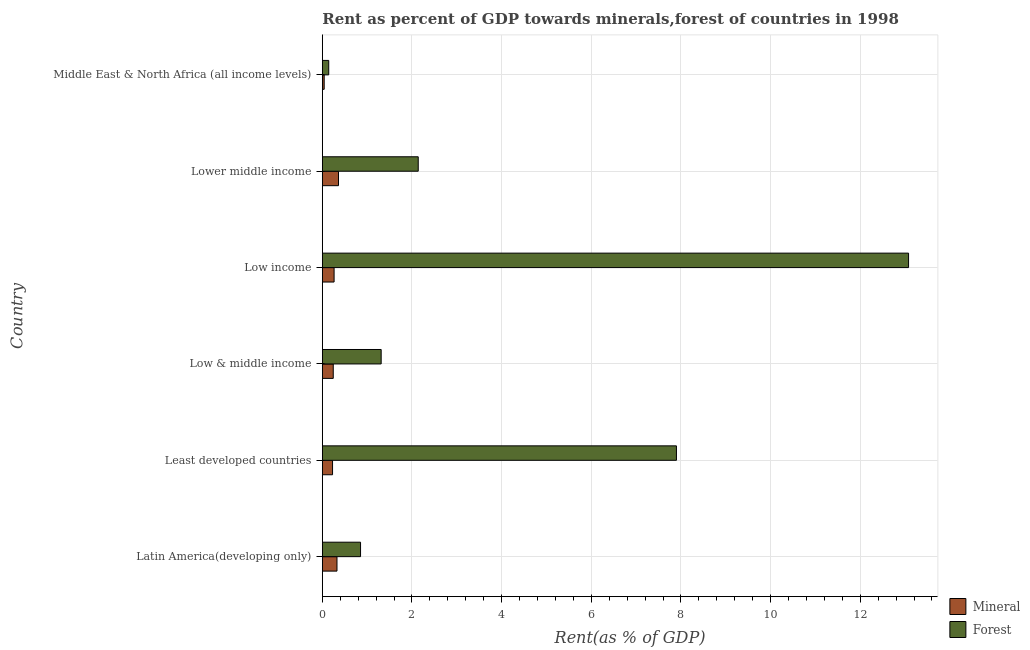How many different coloured bars are there?
Offer a very short reply. 2. How many groups of bars are there?
Provide a succinct answer. 6. What is the label of the 5th group of bars from the top?
Make the answer very short. Least developed countries. What is the forest rent in Lower middle income?
Your answer should be compact. 2.14. Across all countries, what is the maximum mineral rent?
Ensure brevity in your answer.  0.36. Across all countries, what is the minimum mineral rent?
Keep it short and to the point. 0.04. In which country was the mineral rent minimum?
Provide a succinct answer. Middle East & North Africa (all income levels). What is the total forest rent in the graph?
Your response must be concise. 25.42. What is the difference between the mineral rent in Low income and that in Lower middle income?
Offer a terse response. -0.1. What is the difference between the forest rent in Latin America(developing only) and the mineral rent in Low income?
Provide a succinct answer. 0.59. What is the average forest rent per country?
Your response must be concise. 4.24. What is the difference between the mineral rent and forest rent in Low & middle income?
Your response must be concise. -1.07. In how many countries, is the mineral rent greater than 12.4 %?
Provide a short and direct response. 0. What is the ratio of the mineral rent in Lower middle income to that in Middle East & North Africa (all income levels)?
Offer a terse response. 8.7. Is the forest rent in Least developed countries less than that in Low & middle income?
Provide a short and direct response. No. What is the difference between the highest and the second highest forest rent?
Give a very brief answer. 5.18. What is the difference between the highest and the lowest forest rent?
Make the answer very short. 12.93. In how many countries, is the forest rent greater than the average forest rent taken over all countries?
Offer a very short reply. 2. Is the sum of the mineral rent in Least developed countries and Low & middle income greater than the maximum forest rent across all countries?
Your answer should be compact. No. What does the 2nd bar from the top in Low income represents?
Your answer should be very brief. Mineral. What does the 1st bar from the bottom in Low income represents?
Your answer should be compact. Mineral. Are all the bars in the graph horizontal?
Your answer should be compact. Yes. What is the difference between two consecutive major ticks on the X-axis?
Your answer should be very brief. 2. Does the graph contain any zero values?
Your answer should be compact. No. How are the legend labels stacked?
Provide a short and direct response. Vertical. What is the title of the graph?
Offer a very short reply. Rent as percent of GDP towards minerals,forest of countries in 1998. What is the label or title of the X-axis?
Your answer should be very brief. Rent(as % of GDP). What is the label or title of the Y-axis?
Provide a succinct answer. Country. What is the Rent(as % of GDP) of Mineral in Latin America(developing only)?
Your answer should be compact. 0.33. What is the Rent(as % of GDP) of Forest in Latin America(developing only)?
Provide a short and direct response. 0.85. What is the Rent(as % of GDP) of Mineral in Least developed countries?
Provide a short and direct response. 0.23. What is the Rent(as % of GDP) in Forest in Least developed countries?
Ensure brevity in your answer.  7.9. What is the Rent(as % of GDP) in Mineral in Low & middle income?
Provide a short and direct response. 0.24. What is the Rent(as % of GDP) in Forest in Low & middle income?
Your response must be concise. 1.31. What is the Rent(as % of GDP) of Mineral in Low income?
Offer a terse response. 0.26. What is the Rent(as % of GDP) of Forest in Low income?
Make the answer very short. 13.08. What is the Rent(as % of GDP) in Mineral in Lower middle income?
Make the answer very short. 0.36. What is the Rent(as % of GDP) in Forest in Lower middle income?
Offer a terse response. 2.14. What is the Rent(as % of GDP) of Mineral in Middle East & North Africa (all income levels)?
Offer a very short reply. 0.04. What is the Rent(as % of GDP) in Forest in Middle East & North Africa (all income levels)?
Provide a succinct answer. 0.14. Across all countries, what is the maximum Rent(as % of GDP) in Mineral?
Provide a succinct answer. 0.36. Across all countries, what is the maximum Rent(as % of GDP) of Forest?
Your answer should be compact. 13.08. Across all countries, what is the minimum Rent(as % of GDP) of Mineral?
Offer a terse response. 0.04. Across all countries, what is the minimum Rent(as % of GDP) in Forest?
Provide a short and direct response. 0.14. What is the total Rent(as % of GDP) of Mineral in the graph?
Offer a terse response. 1.46. What is the total Rent(as % of GDP) of Forest in the graph?
Your answer should be very brief. 25.42. What is the difference between the Rent(as % of GDP) in Mineral in Latin America(developing only) and that in Least developed countries?
Make the answer very short. 0.1. What is the difference between the Rent(as % of GDP) of Forest in Latin America(developing only) and that in Least developed countries?
Offer a terse response. -7.05. What is the difference between the Rent(as % of GDP) of Mineral in Latin America(developing only) and that in Low & middle income?
Ensure brevity in your answer.  0.08. What is the difference between the Rent(as % of GDP) of Forest in Latin America(developing only) and that in Low & middle income?
Make the answer very short. -0.46. What is the difference between the Rent(as % of GDP) of Mineral in Latin America(developing only) and that in Low income?
Your answer should be compact. 0.06. What is the difference between the Rent(as % of GDP) in Forest in Latin America(developing only) and that in Low income?
Offer a terse response. -12.22. What is the difference between the Rent(as % of GDP) in Mineral in Latin America(developing only) and that in Lower middle income?
Make the answer very short. -0.03. What is the difference between the Rent(as % of GDP) of Forest in Latin America(developing only) and that in Lower middle income?
Keep it short and to the point. -1.29. What is the difference between the Rent(as % of GDP) of Mineral in Latin America(developing only) and that in Middle East & North Africa (all income levels)?
Give a very brief answer. 0.29. What is the difference between the Rent(as % of GDP) of Forest in Latin America(developing only) and that in Middle East & North Africa (all income levels)?
Keep it short and to the point. 0.71. What is the difference between the Rent(as % of GDP) in Mineral in Least developed countries and that in Low & middle income?
Provide a short and direct response. -0.02. What is the difference between the Rent(as % of GDP) in Forest in Least developed countries and that in Low & middle income?
Your answer should be compact. 6.59. What is the difference between the Rent(as % of GDP) of Mineral in Least developed countries and that in Low income?
Provide a short and direct response. -0.03. What is the difference between the Rent(as % of GDP) in Forest in Least developed countries and that in Low income?
Keep it short and to the point. -5.18. What is the difference between the Rent(as % of GDP) in Mineral in Least developed countries and that in Lower middle income?
Offer a very short reply. -0.13. What is the difference between the Rent(as % of GDP) in Forest in Least developed countries and that in Lower middle income?
Provide a short and direct response. 5.76. What is the difference between the Rent(as % of GDP) of Mineral in Least developed countries and that in Middle East & North Africa (all income levels)?
Your answer should be very brief. 0.19. What is the difference between the Rent(as % of GDP) of Forest in Least developed countries and that in Middle East & North Africa (all income levels)?
Your answer should be compact. 7.76. What is the difference between the Rent(as % of GDP) in Mineral in Low & middle income and that in Low income?
Give a very brief answer. -0.02. What is the difference between the Rent(as % of GDP) of Forest in Low & middle income and that in Low income?
Your response must be concise. -11.76. What is the difference between the Rent(as % of GDP) in Mineral in Low & middle income and that in Lower middle income?
Provide a short and direct response. -0.12. What is the difference between the Rent(as % of GDP) of Forest in Low & middle income and that in Lower middle income?
Your answer should be very brief. -0.83. What is the difference between the Rent(as % of GDP) of Mineral in Low & middle income and that in Middle East & North Africa (all income levels)?
Your response must be concise. 0.2. What is the difference between the Rent(as % of GDP) in Forest in Low & middle income and that in Middle East & North Africa (all income levels)?
Offer a very short reply. 1.17. What is the difference between the Rent(as % of GDP) of Mineral in Low income and that in Lower middle income?
Ensure brevity in your answer.  -0.1. What is the difference between the Rent(as % of GDP) in Forest in Low income and that in Lower middle income?
Your response must be concise. 10.94. What is the difference between the Rent(as % of GDP) in Mineral in Low income and that in Middle East & North Africa (all income levels)?
Your answer should be compact. 0.22. What is the difference between the Rent(as % of GDP) in Forest in Low income and that in Middle East & North Africa (all income levels)?
Ensure brevity in your answer.  12.93. What is the difference between the Rent(as % of GDP) of Mineral in Lower middle income and that in Middle East & North Africa (all income levels)?
Your answer should be very brief. 0.32. What is the difference between the Rent(as % of GDP) in Forest in Lower middle income and that in Middle East & North Africa (all income levels)?
Make the answer very short. 2. What is the difference between the Rent(as % of GDP) in Mineral in Latin America(developing only) and the Rent(as % of GDP) in Forest in Least developed countries?
Your answer should be very brief. -7.57. What is the difference between the Rent(as % of GDP) in Mineral in Latin America(developing only) and the Rent(as % of GDP) in Forest in Low & middle income?
Make the answer very short. -0.99. What is the difference between the Rent(as % of GDP) in Mineral in Latin America(developing only) and the Rent(as % of GDP) in Forest in Low income?
Provide a succinct answer. -12.75. What is the difference between the Rent(as % of GDP) in Mineral in Latin America(developing only) and the Rent(as % of GDP) in Forest in Lower middle income?
Make the answer very short. -1.81. What is the difference between the Rent(as % of GDP) in Mineral in Latin America(developing only) and the Rent(as % of GDP) in Forest in Middle East & North Africa (all income levels)?
Provide a short and direct response. 0.18. What is the difference between the Rent(as % of GDP) of Mineral in Least developed countries and the Rent(as % of GDP) of Forest in Low & middle income?
Make the answer very short. -1.08. What is the difference between the Rent(as % of GDP) of Mineral in Least developed countries and the Rent(as % of GDP) of Forest in Low income?
Make the answer very short. -12.85. What is the difference between the Rent(as % of GDP) of Mineral in Least developed countries and the Rent(as % of GDP) of Forest in Lower middle income?
Your answer should be compact. -1.91. What is the difference between the Rent(as % of GDP) in Mineral in Least developed countries and the Rent(as % of GDP) in Forest in Middle East & North Africa (all income levels)?
Your response must be concise. 0.08. What is the difference between the Rent(as % of GDP) of Mineral in Low & middle income and the Rent(as % of GDP) of Forest in Low income?
Give a very brief answer. -12.83. What is the difference between the Rent(as % of GDP) of Mineral in Low & middle income and the Rent(as % of GDP) of Forest in Lower middle income?
Offer a very short reply. -1.9. What is the difference between the Rent(as % of GDP) of Mineral in Low & middle income and the Rent(as % of GDP) of Forest in Middle East & North Africa (all income levels)?
Give a very brief answer. 0.1. What is the difference between the Rent(as % of GDP) of Mineral in Low income and the Rent(as % of GDP) of Forest in Lower middle income?
Make the answer very short. -1.88. What is the difference between the Rent(as % of GDP) of Mineral in Low income and the Rent(as % of GDP) of Forest in Middle East & North Africa (all income levels)?
Provide a succinct answer. 0.12. What is the difference between the Rent(as % of GDP) in Mineral in Lower middle income and the Rent(as % of GDP) in Forest in Middle East & North Africa (all income levels)?
Make the answer very short. 0.22. What is the average Rent(as % of GDP) of Mineral per country?
Offer a terse response. 0.24. What is the average Rent(as % of GDP) in Forest per country?
Your response must be concise. 4.24. What is the difference between the Rent(as % of GDP) in Mineral and Rent(as % of GDP) in Forest in Latin America(developing only)?
Your response must be concise. -0.53. What is the difference between the Rent(as % of GDP) in Mineral and Rent(as % of GDP) in Forest in Least developed countries?
Make the answer very short. -7.67. What is the difference between the Rent(as % of GDP) in Mineral and Rent(as % of GDP) in Forest in Low & middle income?
Give a very brief answer. -1.07. What is the difference between the Rent(as % of GDP) of Mineral and Rent(as % of GDP) of Forest in Low income?
Your response must be concise. -12.81. What is the difference between the Rent(as % of GDP) in Mineral and Rent(as % of GDP) in Forest in Lower middle income?
Give a very brief answer. -1.78. What is the difference between the Rent(as % of GDP) of Mineral and Rent(as % of GDP) of Forest in Middle East & North Africa (all income levels)?
Make the answer very short. -0.1. What is the ratio of the Rent(as % of GDP) of Mineral in Latin America(developing only) to that in Least developed countries?
Offer a very short reply. 1.43. What is the ratio of the Rent(as % of GDP) in Forest in Latin America(developing only) to that in Least developed countries?
Ensure brevity in your answer.  0.11. What is the ratio of the Rent(as % of GDP) in Mineral in Latin America(developing only) to that in Low & middle income?
Your response must be concise. 1.34. What is the ratio of the Rent(as % of GDP) of Forest in Latin America(developing only) to that in Low & middle income?
Your answer should be very brief. 0.65. What is the ratio of the Rent(as % of GDP) in Mineral in Latin America(developing only) to that in Low income?
Ensure brevity in your answer.  1.25. What is the ratio of the Rent(as % of GDP) in Forest in Latin America(developing only) to that in Low income?
Provide a short and direct response. 0.07. What is the ratio of the Rent(as % of GDP) in Mineral in Latin America(developing only) to that in Lower middle income?
Offer a very short reply. 0.91. What is the ratio of the Rent(as % of GDP) of Forest in Latin America(developing only) to that in Lower middle income?
Provide a short and direct response. 0.4. What is the ratio of the Rent(as % of GDP) in Mineral in Latin America(developing only) to that in Middle East & North Africa (all income levels)?
Keep it short and to the point. 7.88. What is the ratio of the Rent(as % of GDP) of Forest in Latin America(developing only) to that in Middle East & North Africa (all income levels)?
Offer a terse response. 5.96. What is the ratio of the Rent(as % of GDP) in Mineral in Least developed countries to that in Low & middle income?
Ensure brevity in your answer.  0.94. What is the ratio of the Rent(as % of GDP) of Forest in Least developed countries to that in Low & middle income?
Give a very brief answer. 6.02. What is the ratio of the Rent(as % of GDP) in Mineral in Least developed countries to that in Low income?
Keep it short and to the point. 0.87. What is the ratio of the Rent(as % of GDP) in Forest in Least developed countries to that in Low income?
Provide a short and direct response. 0.6. What is the ratio of the Rent(as % of GDP) in Mineral in Least developed countries to that in Lower middle income?
Ensure brevity in your answer.  0.63. What is the ratio of the Rent(as % of GDP) in Forest in Least developed countries to that in Lower middle income?
Your answer should be compact. 3.69. What is the ratio of the Rent(as % of GDP) of Mineral in Least developed countries to that in Middle East & North Africa (all income levels)?
Provide a succinct answer. 5.5. What is the ratio of the Rent(as % of GDP) in Forest in Least developed countries to that in Middle East & North Africa (all income levels)?
Provide a succinct answer. 55.24. What is the ratio of the Rent(as % of GDP) in Mineral in Low & middle income to that in Low income?
Provide a short and direct response. 0.93. What is the ratio of the Rent(as % of GDP) of Forest in Low & middle income to that in Low income?
Offer a terse response. 0.1. What is the ratio of the Rent(as % of GDP) in Mineral in Low & middle income to that in Lower middle income?
Keep it short and to the point. 0.68. What is the ratio of the Rent(as % of GDP) in Forest in Low & middle income to that in Lower middle income?
Provide a short and direct response. 0.61. What is the ratio of the Rent(as % of GDP) in Mineral in Low & middle income to that in Middle East & North Africa (all income levels)?
Provide a succinct answer. 5.88. What is the ratio of the Rent(as % of GDP) in Forest in Low & middle income to that in Middle East & North Africa (all income levels)?
Offer a terse response. 9.18. What is the ratio of the Rent(as % of GDP) of Mineral in Low income to that in Lower middle income?
Provide a succinct answer. 0.73. What is the ratio of the Rent(as % of GDP) of Forest in Low income to that in Lower middle income?
Provide a succinct answer. 6.11. What is the ratio of the Rent(as % of GDP) of Mineral in Low income to that in Middle East & North Africa (all income levels)?
Keep it short and to the point. 6.33. What is the ratio of the Rent(as % of GDP) of Forest in Low income to that in Middle East & North Africa (all income levels)?
Give a very brief answer. 91.45. What is the ratio of the Rent(as % of GDP) of Mineral in Lower middle income to that in Middle East & North Africa (all income levels)?
Offer a very short reply. 8.7. What is the ratio of the Rent(as % of GDP) of Forest in Lower middle income to that in Middle East & North Africa (all income levels)?
Offer a terse response. 14.96. What is the difference between the highest and the second highest Rent(as % of GDP) of Mineral?
Provide a short and direct response. 0.03. What is the difference between the highest and the second highest Rent(as % of GDP) of Forest?
Make the answer very short. 5.18. What is the difference between the highest and the lowest Rent(as % of GDP) of Mineral?
Your response must be concise. 0.32. What is the difference between the highest and the lowest Rent(as % of GDP) of Forest?
Provide a short and direct response. 12.93. 